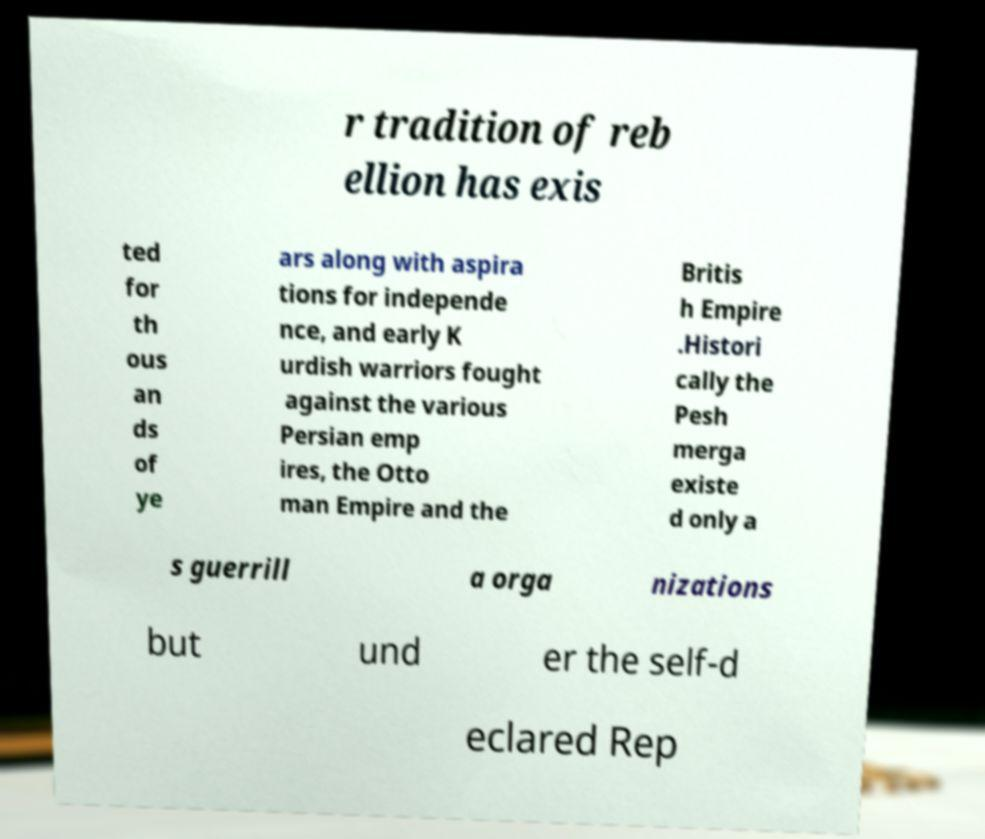Please read and relay the text visible in this image. What does it say? r tradition of reb ellion has exis ted for th ous an ds of ye ars along with aspira tions for independe nce, and early K urdish warriors fought against the various Persian emp ires, the Otto man Empire and the Britis h Empire .Histori cally the Pesh merga existe d only a s guerrill a orga nizations but und er the self-d eclared Rep 